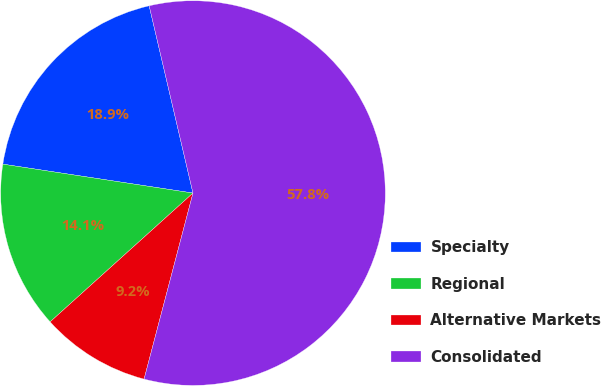<chart> <loc_0><loc_0><loc_500><loc_500><pie_chart><fcel>Specialty<fcel>Regional<fcel>Alternative Markets<fcel>Consolidated<nl><fcel>18.94%<fcel>14.08%<fcel>9.23%<fcel>57.75%<nl></chart> 